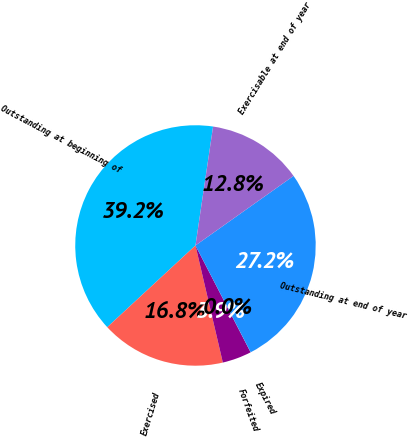Convert chart. <chart><loc_0><loc_0><loc_500><loc_500><pie_chart><fcel>Outstanding at beginning of<fcel>Exercised<fcel>Forfeited<fcel>Expired<fcel>Outstanding at end of year<fcel>Exercisable at end of year<nl><fcel>39.23%<fcel>16.76%<fcel>3.93%<fcel>0.01%<fcel>27.22%<fcel>12.84%<nl></chart> 